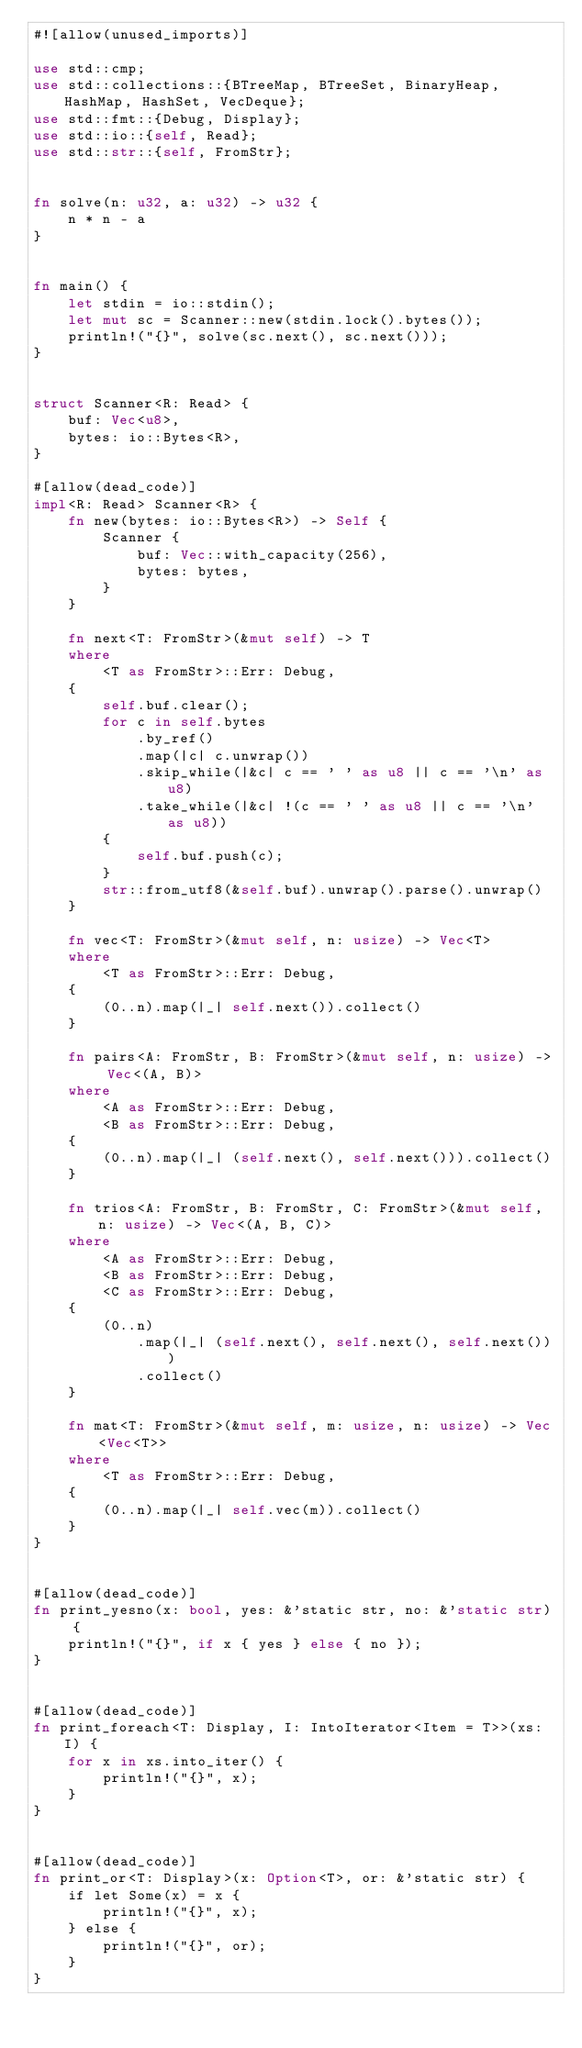<code> <loc_0><loc_0><loc_500><loc_500><_Rust_>#![allow(unused_imports)]

use std::cmp;
use std::collections::{BTreeMap, BTreeSet, BinaryHeap, HashMap, HashSet, VecDeque};
use std::fmt::{Debug, Display};
use std::io::{self, Read};
use std::str::{self, FromStr};


fn solve(n: u32, a: u32) -> u32 {
    n * n - a
}


fn main() {
    let stdin = io::stdin();
    let mut sc = Scanner::new(stdin.lock().bytes());
    println!("{}", solve(sc.next(), sc.next()));
}


struct Scanner<R: Read> {
    buf: Vec<u8>,
    bytes: io::Bytes<R>,
}

#[allow(dead_code)]
impl<R: Read> Scanner<R> {
    fn new(bytes: io::Bytes<R>) -> Self {
        Scanner {
            buf: Vec::with_capacity(256),
            bytes: bytes,
        }
    }

    fn next<T: FromStr>(&mut self) -> T
    where
        <T as FromStr>::Err: Debug,
    {
        self.buf.clear();
        for c in self.bytes
            .by_ref()
            .map(|c| c.unwrap())
            .skip_while(|&c| c == ' ' as u8 || c == '\n' as u8)
            .take_while(|&c| !(c == ' ' as u8 || c == '\n' as u8))
        {
            self.buf.push(c);
        }
        str::from_utf8(&self.buf).unwrap().parse().unwrap()
    }

    fn vec<T: FromStr>(&mut self, n: usize) -> Vec<T>
    where
        <T as FromStr>::Err: Debug,
    {
        (0..n).map(|_| self.next()).collect()
    }

    fn pairs<A: FromStr, B: FromStr>(&mut self, n: usize) -> Vec<(A, B)>
    where
        <A as FromStr>::Err: Debug,
        <B as FromStr>::Err: Debug,
    {
        (0..n).map(|_| (self.next(), self.next())).collect()
    }

    fn trios<A: FromStr, B: FromStr, C: FromStr>(&mut self, n: usize) -> Vec<(A, B, C)>
    where
        <A as FromStr>::Err: Debug,
        <B as FromStr>::Err: Debug,
        <C as FromStr>::Err: Debug,
    {
        (0..n)
            .map(|_| (self.next(), self.next(), self.next()))
            .collect()
    }

    fn mat<T: FromStr>(&mut self, m: usize, n: usize) -> Vec<Vec<T>>
    where
        <T as FromStr>::Err: Debug,
    {
        (0..n).map(|_| self.vec(m)).collect()
    }
}


#[allow(dead_code)]
fn print_yesno(x: bool, yes: &'static str, no: &'static str) {
    println!("{}", if x { yes } else { no });
}


#[allow(dead_code)]
fn print_foreach<T: Display, I: IntoIterator<Item = T>>(xs: I) {
    for x in xs.into_iter() {
        println!("{}", x);
    }
}


#[allow(dead_code)]
fn print_or<T: Display>(x: Option<T>, or: &'static str) {
    if let Some(x) = x {
        println!("{}", x);
    } else {
        println!("{}", or);
    }
}
</code> 